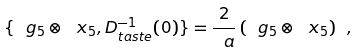<formula> <loc_0><loc_0><loc_500><loc_500>\{ \ g _ { 5 } \otimes \ x _ { 5 } , D _ { t a s t e } ^ { - 1 } ( 0 ) \} = \frac { 2 } { \ a } \, ( \ g _ { 5 } \otimes \ x _ { 5 } ) \ ,</formula> 